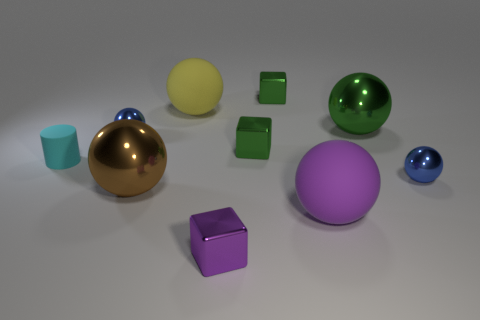Subtract all purple shiny blocks. How many blocks are left? 2 Subtract all cyan cylinders. How many green cubes are left? 2 Subtract all yellow spheres. How many spheres are left? 5 Subtract 1 blocks. How many blocks are left? 2 Subtract all big green metallic spheres. Subtract all large brown metallic balls. How many objects are left? 8 Add 2 cyan objects. How many cyan objects are left? 3 Add 1 large yellow rubber cylinders. How many large yellow rubber cylinders exist? 1 Subtract 0 blue cylinders. How many objects are left? 10 Subtract all cylinders. How many objects are left? 9 Subtract all purple balls. Subtract all purple blocks. How many balls are left? 5 